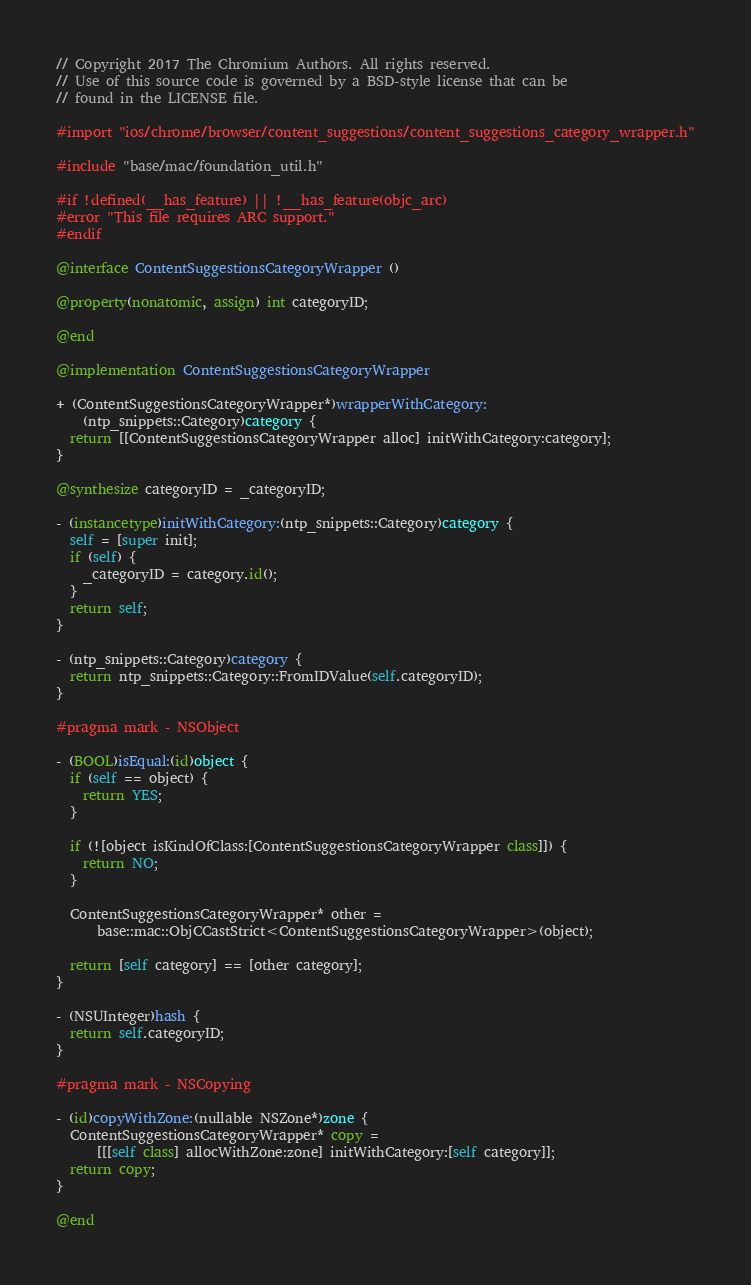<code> <loc_0><loc_0><loc_500><loc_500><_ObjectiveC_>// Copyright 2017 The Chromium Authors. All rights reserved.
// Use of this source code is governed by a BSD-style license that can be
// found in the LICENSE file.

#import "ios/chrome/browser/content_suggestions/content_suggestions_category_wrapper.h"

#include "base/mac/foundation_util.h"

#if !defined(__has_feature) || !__has_feature(objc_arc)
#error "This file requires ARC support."
#endif

@interface ContentSuggestionsCategoryWrapper ()

@property(nonatomic, assign) int categoryID;

@end

@implementation ContentSuggestionsCategoryWrapper

+ (ContentSuggestionsCategoryWrapper*)wrapperWithCategory:
    (ntp_snippets::Category)category {
  return [[ContentSuggestionsCategoryWrapper alloc] initWithCategory:category];
}

@synthesize categoryID = _categoryID;

- (instancetype)initWithCategory:(ntp_snippets::Category)category {
  self = [super init];
  if (self) {
    _categoryID = category.id();
  }
  return self;
}

- (ntp_snippets::Category)category {
  return ntp_snippets::Category::FromIDValue(self.categoryID);
}

#pragma mark - NSObject

- (BOOL)isEqual:(id)object {
  if (self == object) {
    return YES;
  }

  if (![object isKindOfClass:[ContentSuggestionsCategoryWrapper class]]) {
    return NO;
  }

  ContentSuggestionsCategoryWrapper* other =
      base::mac::ObjCCastStrict<ContentSuggestionsCategoryWrapper>(object);

  return [self category] == [other category];
}

- (NSUInteger)hash {
  return self.categoryID;
}

#pragma mark - NSCopying

- (id)copyWithZone:(nullable NSZone*)zone {
  ContentSuggestionsCategoryWrapper* copy =
      [[[self class] allocWithZone:zone] initWithCategory:[self category]];
  return copy;
}

@end
</code> 